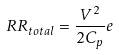Convert formula to latex. <formula><loc_0><loc_0><loc_500><loc_500>R R _ { t o t a l } = \frac { V ^ { 2 } } { 2 C _ { p } } e</formula> 